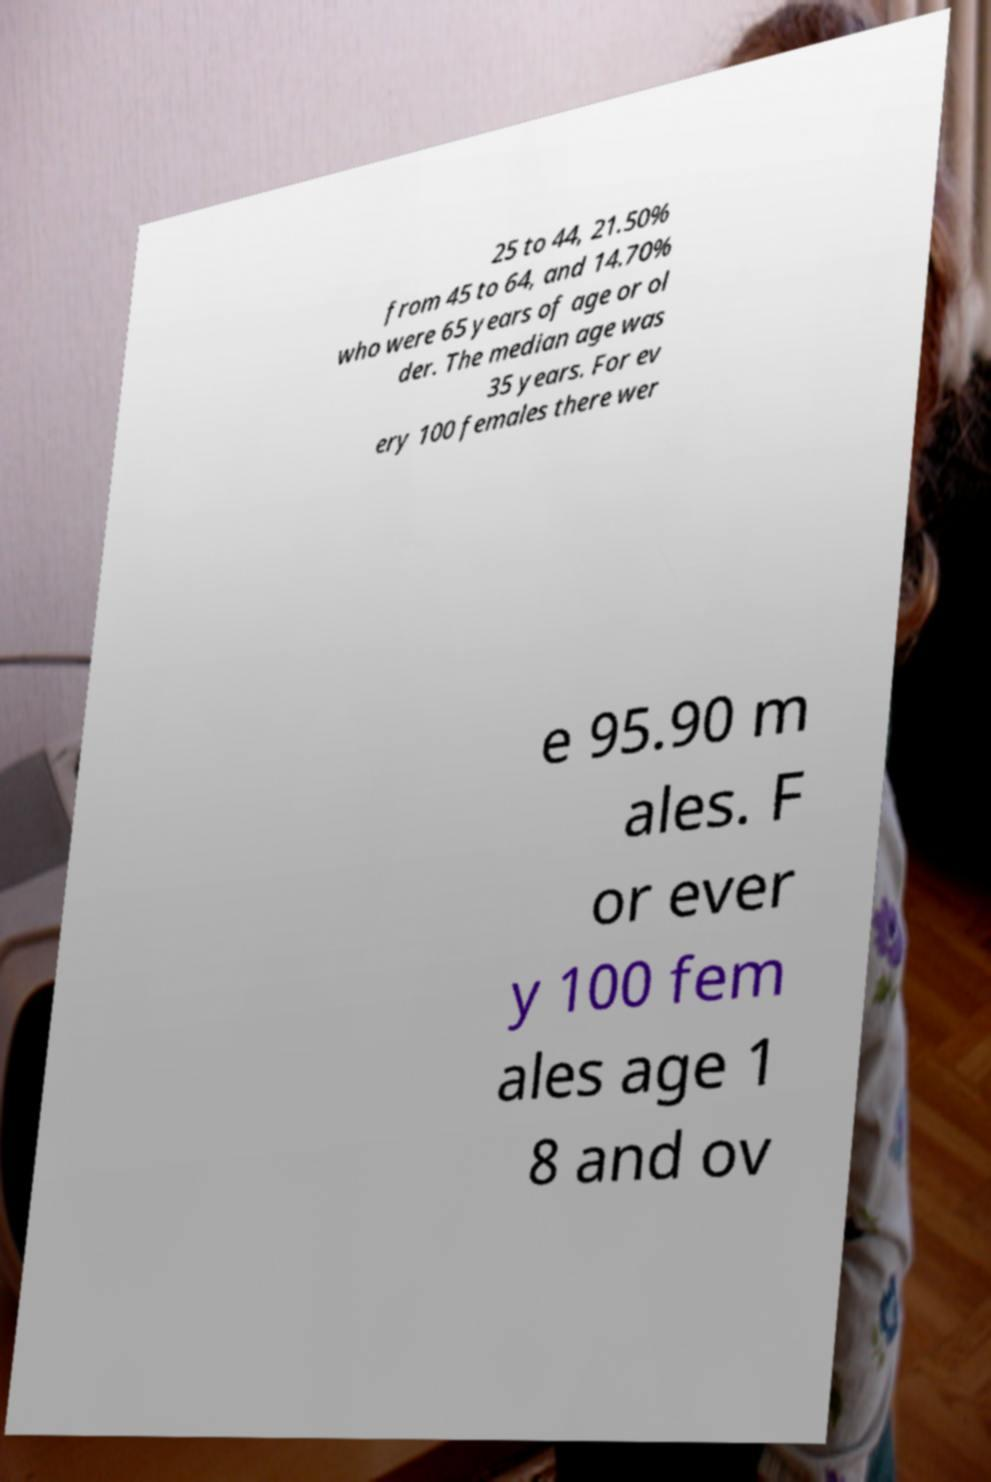There's text embedded in this image that I need extracted. Can you transcribe it verbatim? 25 to 44, 21.50% from 45 to 64, and 14.70% who were 65 years of age or ol der. The median age was 35 years. For ev ery 100 females there wer e 95.90 m ales. F or ever y 100 fem ales age 1 8 and ov 